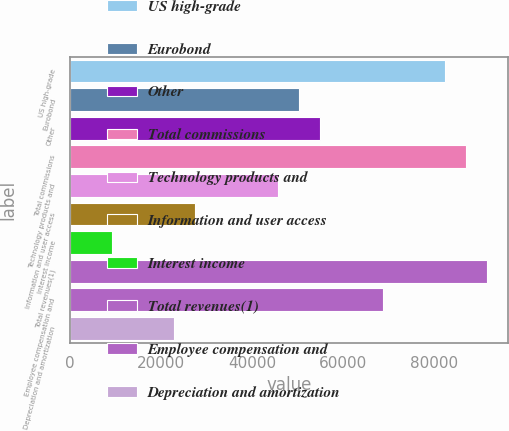Convert chart. <chart><loc_0><loc_0><loc_500><loc_500><bar_chart><fcel>US high-grade<fcel>Eurobond<fcel>Other<fcel>Total commissions<fcel>Technology products and<fcel>Information and user access<fcel>Interest income<fcel>Total revenues(1)<fcel>Employee compensation and<fcel>Depreciation and amortization<nl><fcel>82423.6<fcel>50370.1<fcel>54949.1<fcel>87002.6<fcel>45791<fcel>27474.7<fcel>9158.44<fcel>91581.7<fcel>68686.4<fcel>22895.7<nl></chart> 